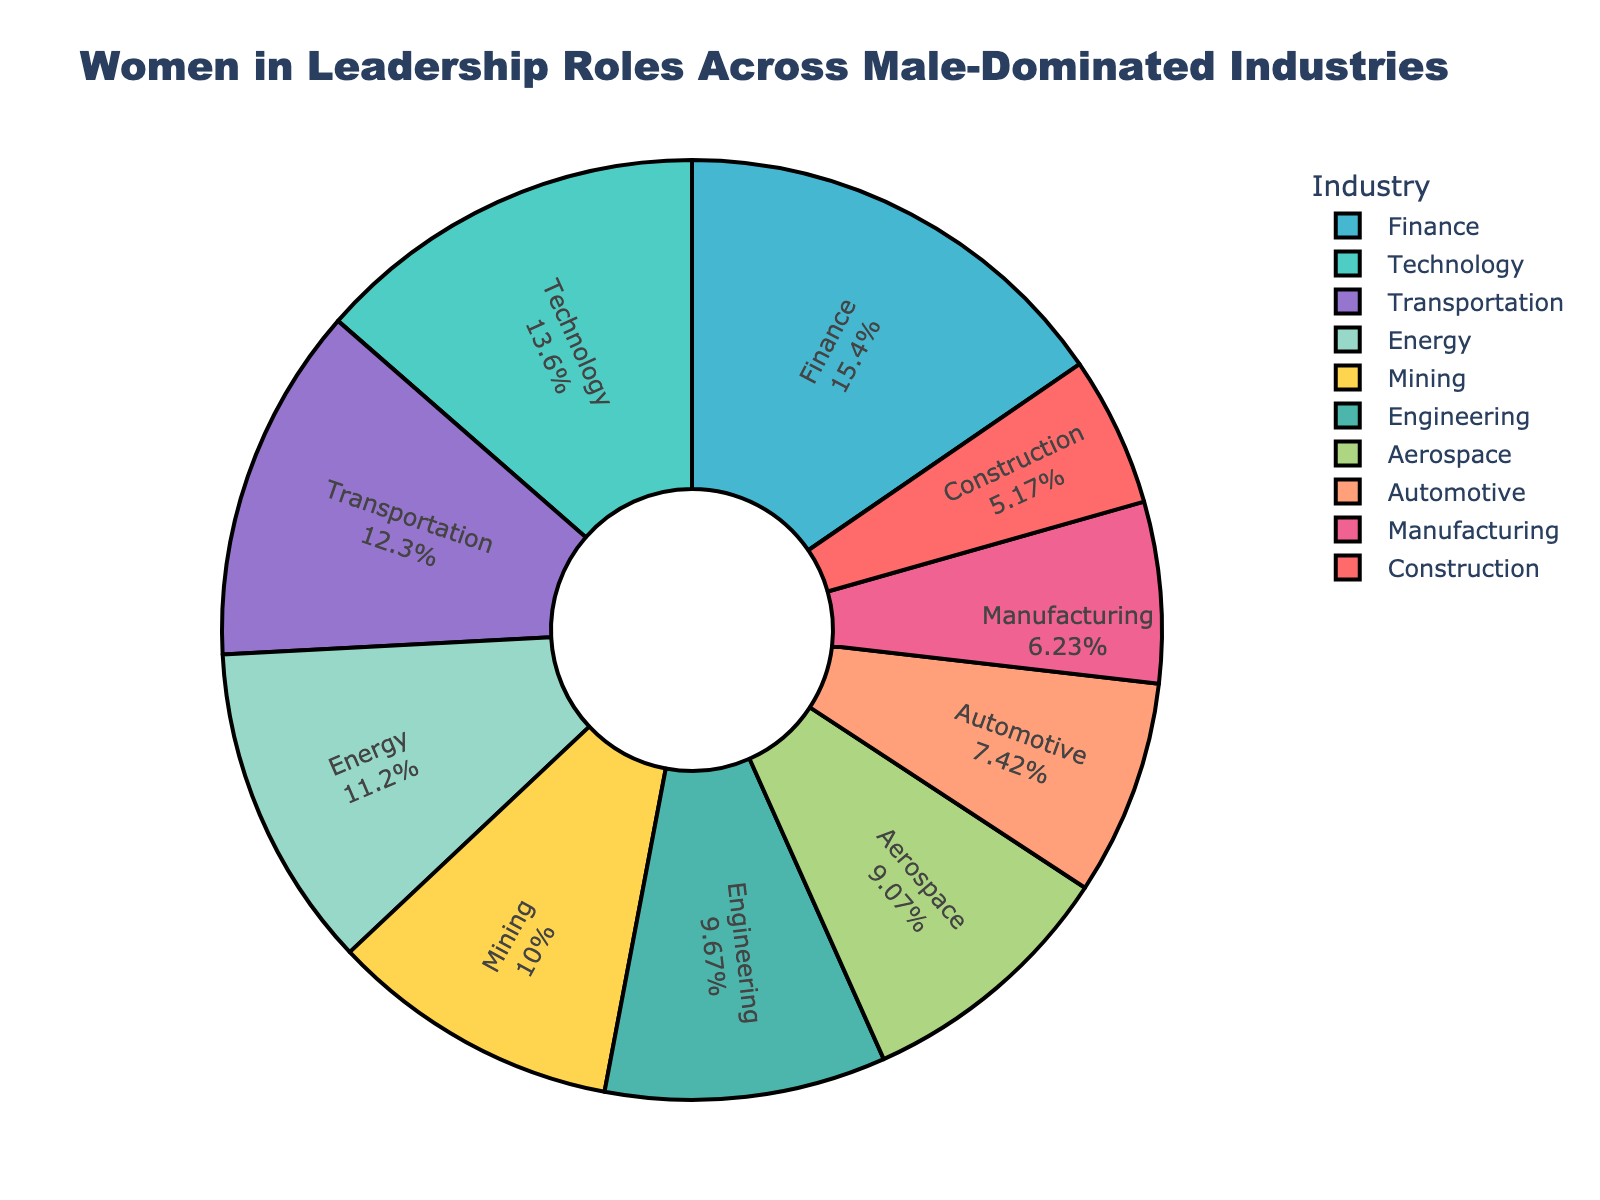What percentage of women are in leadership roles in the Technology industry? The figure shows each industry's percentage of women in leadership roles. For Technology, the pie chart indicates this value at 20.5%.
Answer: 20.5% Which industry has the lowest percentage of women in leadership roles? By examining the pie chart, the Construction industry has the smallest segment, which indicates the lowest percentage of women in leadership roles at 7.8%.
Answer: Construction Is the percentage of women in leadership roles in Finance higher or lower than in Energy? Comparing the segments for Finance and Energy, Finance has a larger segment (23.3%) than Energy (16.9%), indicating a higher percentage.
Answer: Higher Sum the percentage of women in leadership roles for Construction, Manufacturing, and Automotive industries. The pie chart indicates the following percentages: Construction (7.8%), Manufacturing (9.4%), and Automotive (11.2%). Adding these percentages provides 7.8 + 9.4 + 11.2 = 28.4%.
Answer: 28.4% Which industry has a higher percentage of women in leadership roles: Mining or Aerospace? Referring to the chart, Mining has 15.1% and Aerospace has 13.7%. Thus, Mining has a higher percentage of women in leadership roles.
Answer: Mining What is the total percentage of women in leadership roles across the Engineering and Transportation industries? The chart shows 14.6% for Engineering and 18.5% for Transportation. Summing these, we get 14.6 + 18.5 = 33.1%.
Answer: 33.1% Which color represents the Energy industry, and what is its percentage of women in leadership roles? The Energy industry segment is typically marked by a distinct color for this type of chart. If Energy is the color yellow, it is labeled with a 16.9% value.
Answer: (Assumed color) Yellow, 16.9% What is the average percentage of women in leadership roles across all listed industries? To find the average, sum all the percentages and divide by the number of industries: (7.8 + 20.5 + 23.3 + 11.2 + 16.9 + 9.4 + 13.7 + 15.1 + 14.6 + 18.5)/10 = 15.1%.
Answer: 15.1% 